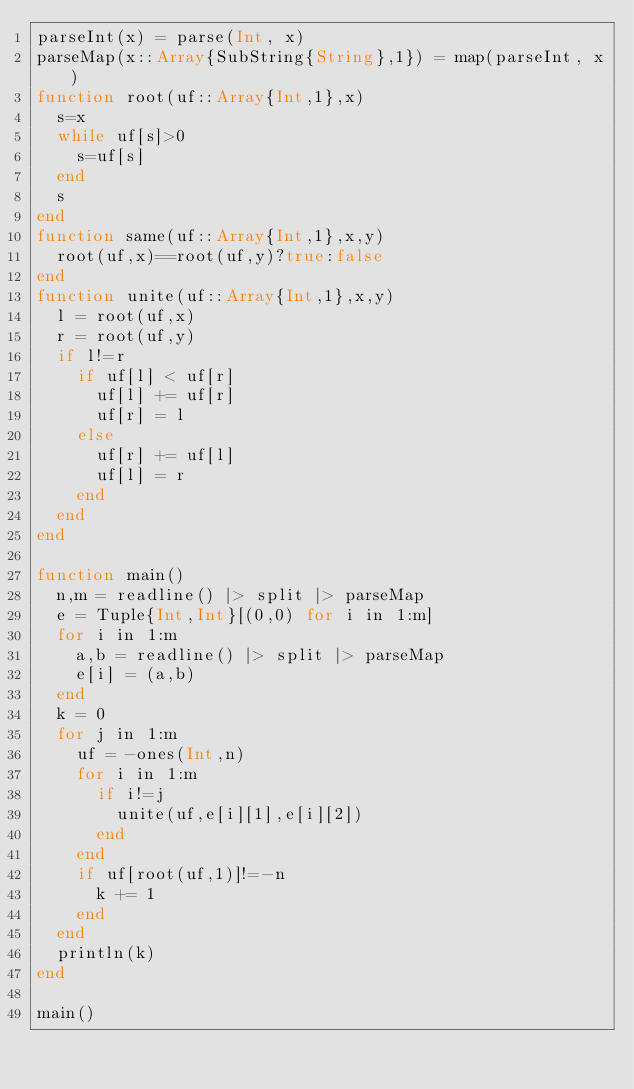<code> <loc_0><loc_0><loc_500><loc_500><_Julia_>parseInt(x) = parse(Int, x)
parseMap(x::Array{SubString{String},1}) = map(parseInt, x)
function root(uf::Array{Int,1},x)
	s=x
	while uf[s]>0
		s=uf[s]
	end
	s
end
function same(uf::Array{Int,1},x,y)
	root(uf,x)==root(uf,y)?true:false
end
function unite(uf::Array{Int,1},x,y)
	l = root(uf,x)
	r = root(uf,y)
	if l!=r
		if uf[l] < uf[r]
			uf[l] += uf[r]
			uf[r] = l
		else
			uf[r] += uf[l]
			uf[l] = r
		end
	end
end

function main()
	n,m = readline() |> split |> parseMap
	e = Tuple{Int,Int}[(0,0) for i in 1:m]
	for i in 1:m
		a,b = readline() |> split |> parseMap
		e[i] = (a,b)
	end
	k = 0
	for j in 1:m
		uf = -ones(Int,n)
		for i in 1:m
			if i!=j
				unite(uf,e[i][1],e[i][2])
			end
		end
		if uf[root(uf,1)]!=-n
			k += 1
		end
	end
	println(k)
end

main()</code> 